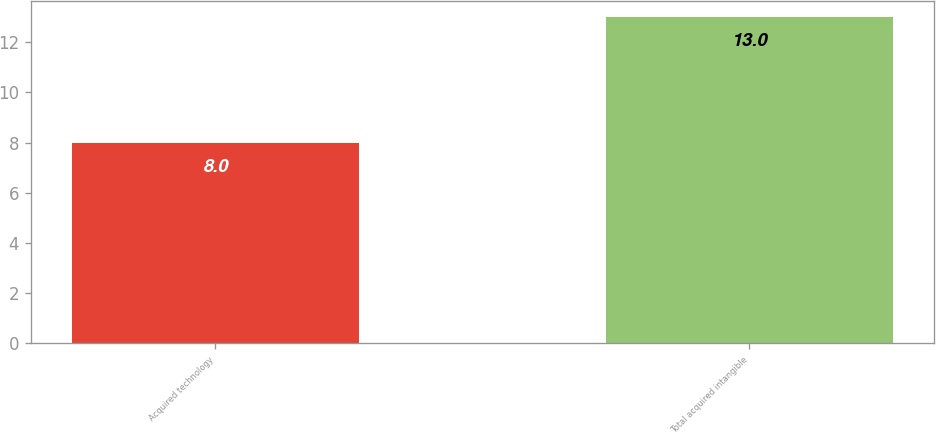<chart> <loc_0><loc_0><loc_500><loc_500><bar_chart><fcel>Acquired technology<fcel>Total acquired intangible<nl><fcel>8<fcel>13<nl></chart> 